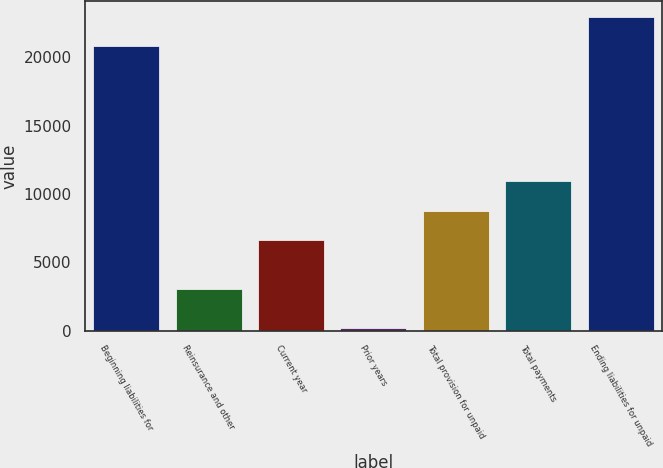Convert chart. <chart><loc_0><loc_0><loc_500><loc_500><bar_chart><fcel>Beginning liabilities for<fcel>Reinsurance and other<fcel>Current year<fcel>Prior years<fcel>Total provision for unpaid<fcel>Total payments<fcel>Ending liabilities for unpaid<nl><fcel>20828.4<fcel>3027<fcel>6621<fcel>192<fcel>8773.4<fcel>10925.8<fcel>22980.8<nl></chart> 